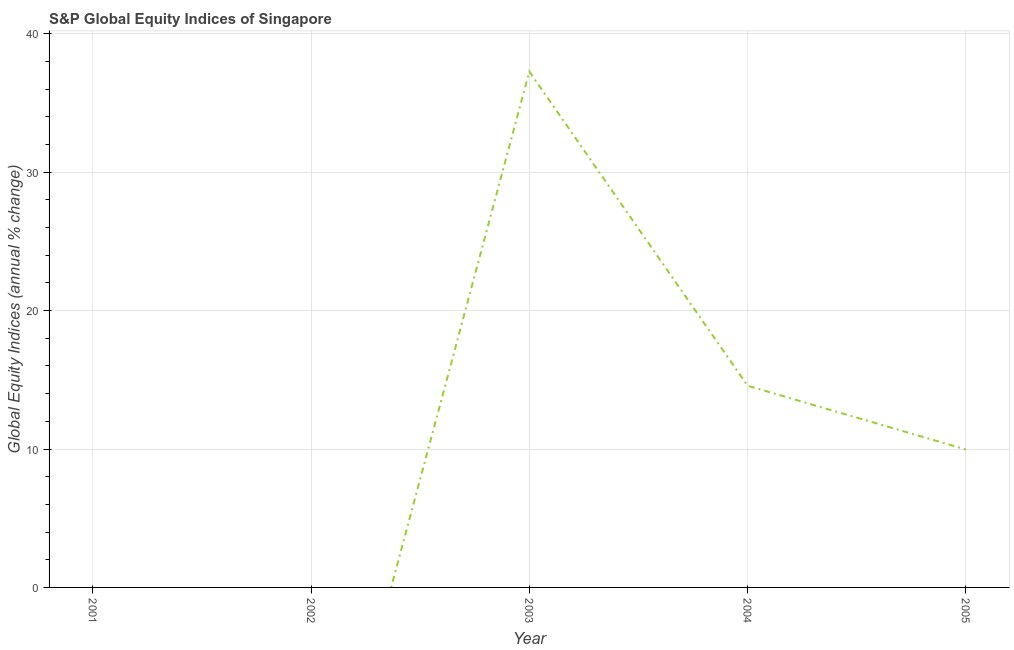What is the s&p global equity indices in 2004?
Keep it short and to the point. 14.57. Across all years, what is the maximum s&p global equity indices?
Your answer should be compact. 37.27. Across all years, what is the minimum s&p global equity indices?
Provide a short and direct response. 0. What is the sum of the s&p global equity indices?
Give a very brief answer. 61.81. What is the difference between the s&p global equity indices in 2004 and 2005?
Offer a terse response. 4.61. What is the average s&p global equity indices per year?
Offer a terse response. 12.36. What is the median s&p global equity indices?
Your answer should be compact. 9.97. In how many years, is the s&p global equity indices greater than 2 %?
Provide a short and direct response. 3. What is the ratio of the s&p global equity indices in 2003 to that in 2005?
Your response must be concise. 3.74. What is the difference between the highest and the second highest s&p global equity indices?
Your answer should be very brief. 22.7. What is the difference between the highest and the lowest s&p global equity indices?
Your answer should be very brief. 37.27. In how many years, is the s&p global equity indices greater than the average s&p global equity indices taken over all years?
Keep it short and to the point. 2. Does the s&p global equity indices monotonically increase over the years?
Provide a succinct answer. No. How many lines are there?
Make the answer very short. 1. What is the difference between two consecutive major ticks on the Y-axis?
Give a very brief answer. 10. Are the values on the major ticks of Y-axis written in scientific E-notation?
Your answer should be very brief. No. Does the graph contain any zero values?
Provide a succinct answer. Yes. What is the title of the graph?
Your answer should be compact. S&P Global Equity Indices of Singapore. What is the label or title of the X-axis?
Give a very brief answer. Year. What is the label or title of the Y-axis?
Provide a succinct answer. Global Equity Indices (annual % change). What is the Global Equity Indices (annual % change) in 2003?
Offer a terse response. 37.27. What is the Global Equity Indices (annual % change) in 2004?
Make the answer very short. 14.57. What is the Global Equity Indices (annual % change) in 2005?
Provide a short and direct response. 9.97. What is the difference between the Global Equity Indices (annual % change) in 2003 and 2004?
Offer a very short reply. 22.7. What is the difference between the Global Equity Indices (annual % change) in 2003 and 2005?
Give a very brief answer. 27.31. What is the difference between the Global Equity Indices (annual % change) in 2004 and 2005?
Keep it short and to the point. 4.61. What is the ratio of the Global Equity Indices (annual % change) in 2003 to that in 2004?
Your answer should be compact. 2.56. What is the ratio of the Global Equity Indices (annual % change) in 2003 to that in 2005?
Keep it short and to the point. 3.74. What is the ratio of the Global Equity Indices (annual % change) in 2004 to that in 2005?
Your response must be concise. 1.46. 